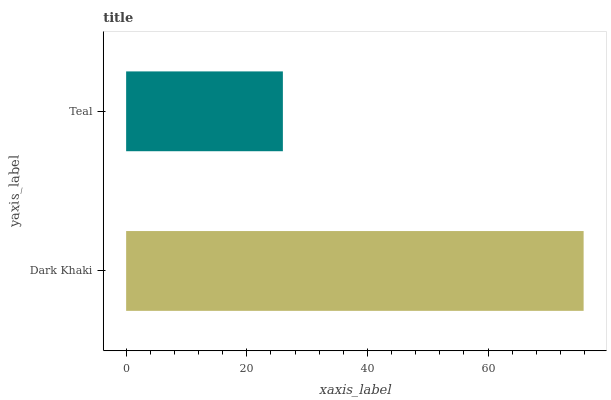Is Teal the minimum?
Answer yes or no. Yes. Is Dark Khaki the maximum?
Answer yes or no. Yes. Is Teal the maximum?
Answer yes or no. No. Is Dark Khaki greater than Teal?
Answer yes or no. Yes. Is Teal less than Dark Khaki?
Answer yes or no. Yes. Is Teal greater than Dark Khaki?
Answer yes or no. No. Is Dark Khaki less than Teal?
Answer yes or no. No. Is Dark Khaki the high median?
Answer yes or no. Yes. Is Teal the low median?
Answer yes or no. Yes. Is Teal the high median?
Answer yes or no. No. Is Dark Khaki the low median?
Answer yes or no. No. 